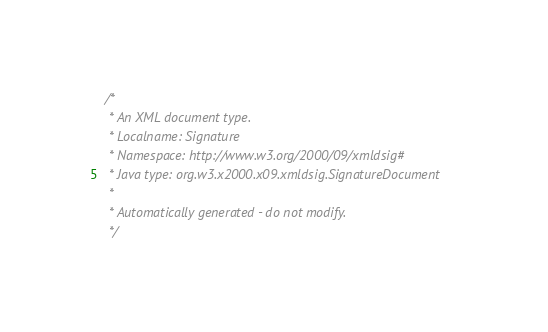<code> <loc_0><loc_0><loc_500><loc_500><_Java_>/*
 * An XML document type.
 * Localname: Signature
 * Namespace: http://www.w3.org/2000/09/xmldsig#
 * Java type: org.w3.x2000.x09.xmldsig.SignatureDocument
 *
 * Automatically generated - do not modify.
 */</code> 